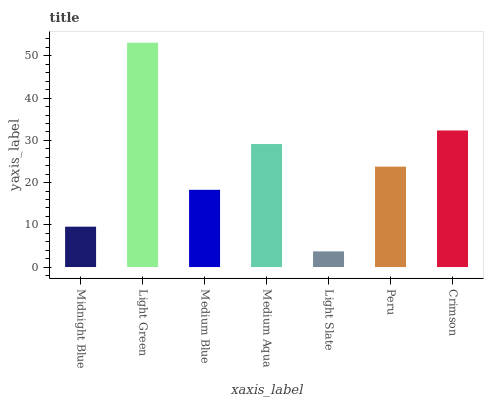Is Light Slate the minimum?
Answer yes or no. Yes. Is Light Green the maximum?
Answer yes or no. Yes. Is Medium Blue the minimum?
Answer yes or no. No. Is Medium Blue the maximum?
Answer yes or no. No. Is Light Green greater than Medium Blue?
Answer yes or no. Yes. Is Medium Blue less than Light Green?
Answer yes or no. Yes. Is Medium Blue greater than Light Green?
Answer yes or no. No. Is Light Green less than Medium Blue?
Answer yes or no. No. Is Peru the high median?
Answer yes or no. Yes. Is Peru the low median?
Answer yes or no. Yes. Is Midnight Blue the high median?
Answer yes or no. No. Is Medium Blue the low median?
Answer yes or no. No. 